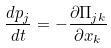<formula> <loc_0><loc_0><loc_500><loc_500>\frac { d p _ { j } } { d t } = - \frac { \partial \Pi _ { j k } } { \partial x _ { k } }</formula> 